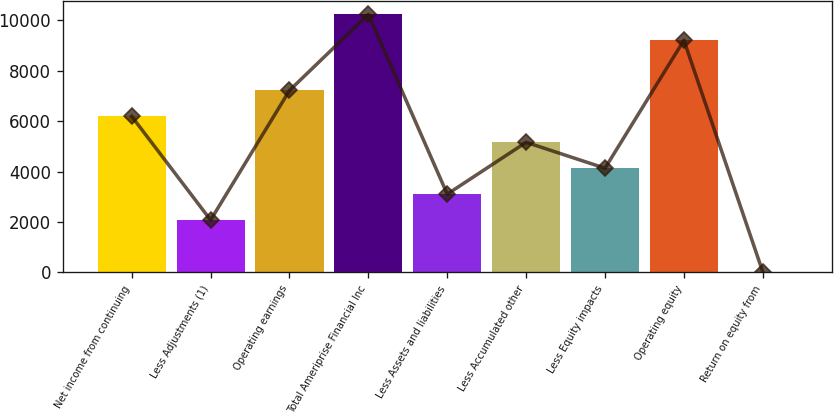Convert chart. <chart><loc_0><loc_0><loc_500><loc_500><bar_chart><fcel>Net income from continuing<fcel>Less Adjustments (1)<fcel>Operating earnings<fcel>Total Ameriprise Financial Inc<fcel>Less Assets and liabilities<fcel>Less Accumulated other<fcel>Less Equity impacts<fcel>Operating equity<fcel>Return on equity from<nl><fcel>6190.04<fcel>2071.08<fcel>7219.78<fcel>10241.7<fcel>3100.82<fcel>5160.3<fcel>4130.56<fcel>9212<fcel>11.6<nl></chart> 